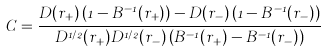Convert formula to latex. <formula><loc_0><loc_0><loc_500><loc_500>C = \frac { D ( r _ { + } ) \left ( 1 - B ^ { - 1 } ( r _ { + } ) \right ) - D ( r _ { - } ) \left ( 1 - B ^ { - 1 } ( r _ { - } ) \right ) } { D ^ { 1 / 2 } ( r _ { + } ) D ^ { 1 / 2 } ( r _ { - } ) \left ( B ^ { - 1 } ( r _ { + } ) - B ^ { - 1 } ( r _ { - } ) \right ) } \,</formula> 